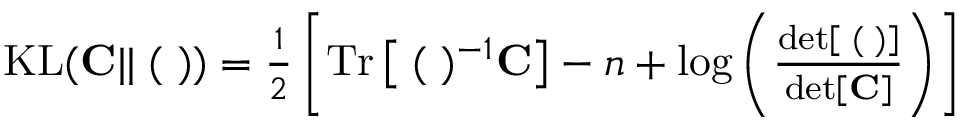<formula> <loc_0><loc_0><loc_500><loc_500>\begin{array} { r } { K L ( { C } | | { \Xi } ( { \Lambda } ) ) = \frac { 1 } { 2 } \left [ T r \left [ { \Xi } ( { \Lambda } ) ^ { - 1 } { C } \right ] - n + \log \left ( \frac { d e t \left [ { \Xi } ( { \Lambda } ) \right ] } { d e t \left [ { C } \right ] } \right ) \right ] } \end{array}</formula> 